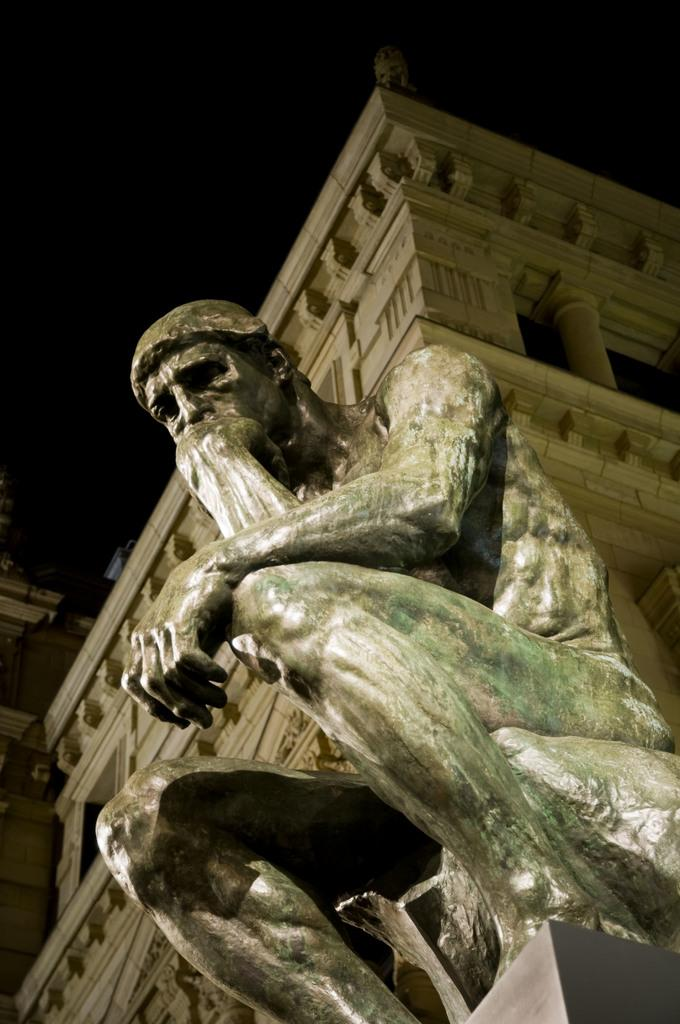What is the main subject in the foreground of the image? There is a sculpture in the foreground of the image. What can be seen in the background of the image? There is a building in the background of the image. What is visible at the top of the image? The sky is visible at the top of the image. What type of fiction is being read by the sculpture in the image? There is no indication that the sculpture is reading any fiction in the image, as sculptures are not capable of reading. 